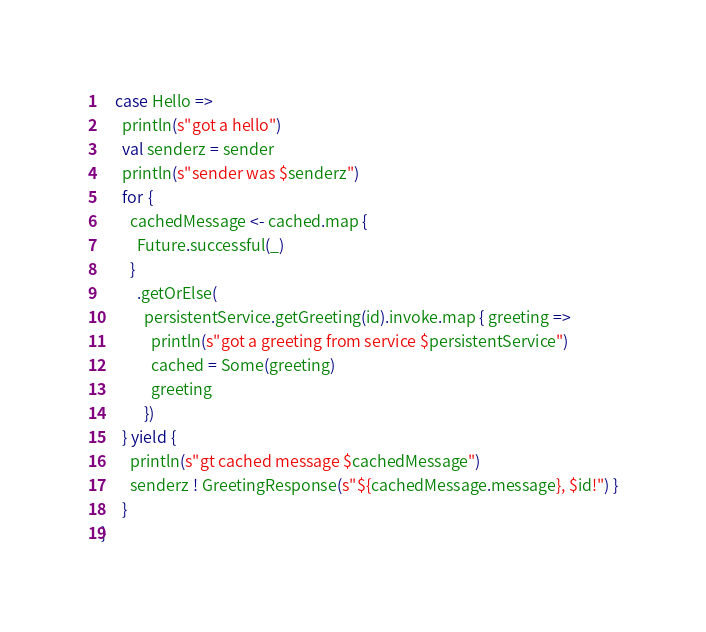Convert code to text. <code><loc_0><loc_0><loc_500><loc_500><_Scala_>    case Hello =>
      println(s"got a hello")
      val senderz = sender
      println(s"sender was $senderz")
      for {
        cachedMessage <- cached.map {
          Future.successful(_)
        }
          .getOrElse(
            persistentService.getGreeting(id).invoke.map { greeting =>
              println(s"got a greeting from service $persistentService")
              cached = Some(greeting)
              greeting
            })
      } yield {
        println(s"gt cached message $cachedMessage")
        senderz ! GreetingResponse(s"${cachedMessage.message}, $id!") }
      }
}

</code> 